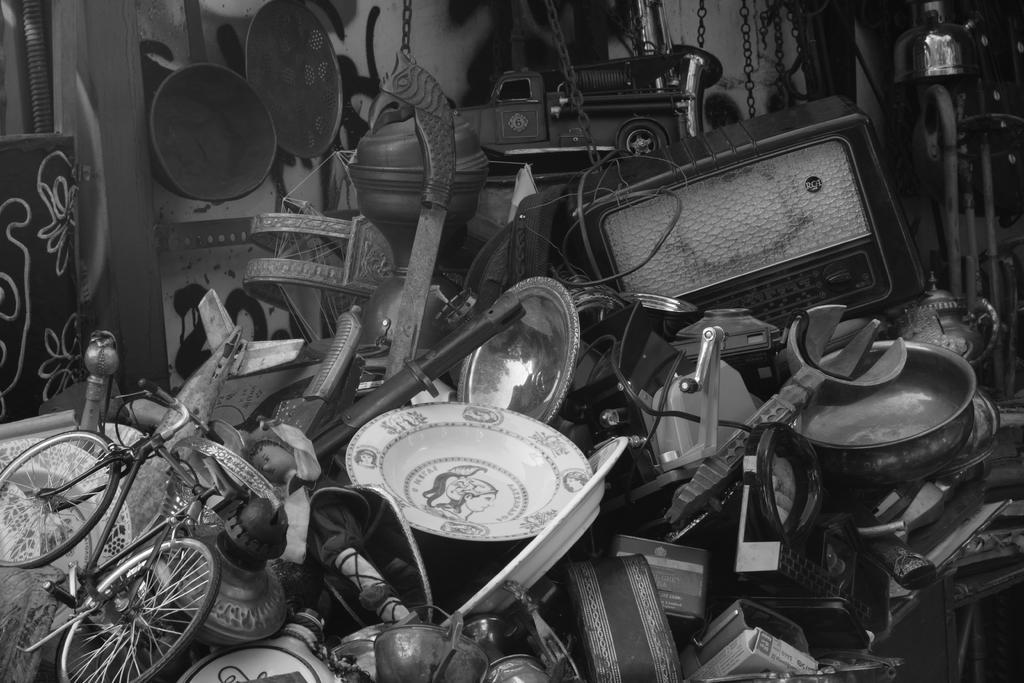In one or two sentences, can you explain what this image depicts? In this picture we can see a bicycle, plates, bowls, pans, chains, a toy car and other things. 